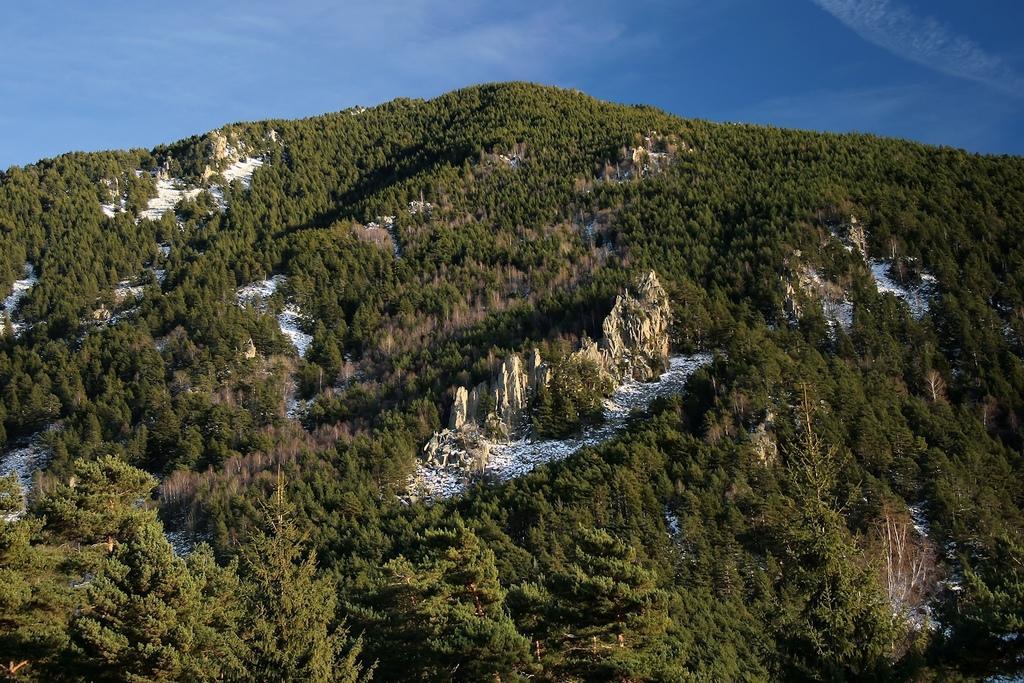Could you give a brief overview of what you see in this image? These are the trees on the hills, at the top it's a blue color sky. 